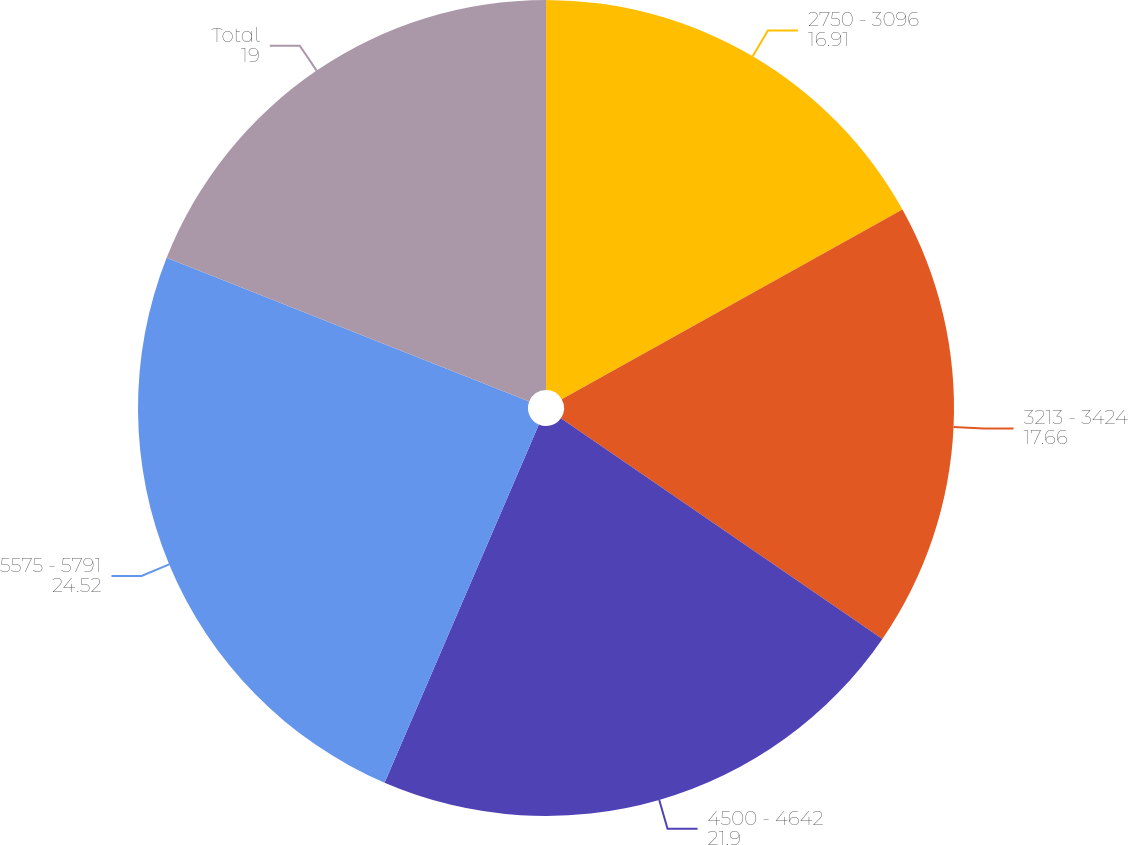<chart> <loc_0><loc_0><loc_500><loc_500><pie_chart><fcel>2750 - 3096<fcel>3213 - 3424<fcel>4500 - 4642<fcel>5575 - 5791<fcel>Total<nl><fcel>16.91%<fcel>17.66%<fcel>21.9%<fcel>24.52%<fcel>19.0%<nl></chart> 